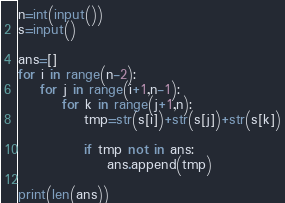Convert code to text. <code><loc_0><loc_0><loc_500><loc_500><_Python_>n=int(input())
s=input()

ans=[]
for i in range(n-2):
    for j in range(i+1,n-1):
        for k in range(j+1,n):
            tmp=str(s[i])+str(s[j])+str(s[k])

            if tmp not in ans:
                ans.append(tmp)

print(len(ans))</code> 